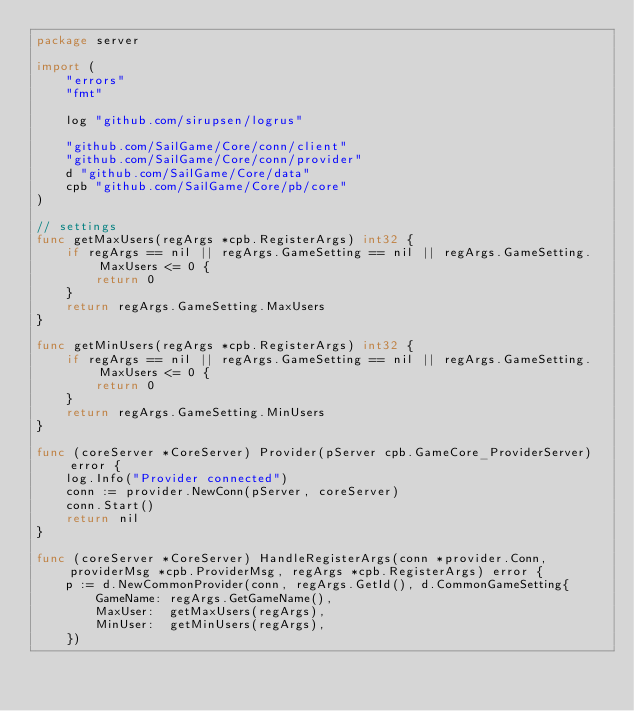Convert code to text. <code><loc_0><loc_0><loc_500><loc_500><_Go_>package server

import (
	"errors"
	"fmt"

	log "github.com/sirupsen/logrus"

	"github.com/SailGame/Core/conn/client"
	"github.com/SailGame/Core/conn/provider"
	d "github.com/SailGame/Core/data"
	cpb "github.com/SailGame/Core/pb/core"
)

// settings
func getMaxUsers(regArgs *cpb.RegisterArgs) int32 {
	if regArgs == nil || regArgs.GameSetting == nil || regArgs.GameSetting.MaxUsers <= 0 {
		return 0
	}
	return regArgs.GameSetting.MaxUsers
}

func getMinUsers(regArgs *cpb.RegisterArgs) int32 {
	if regArgs == nil || regArgs.GameSetting == nil || regArgs.GameSetting.MaxUsers <= 0 {
		return 0
	}
	return regArgs.GameSetting.MinUsers
}

func (coreServer *CoreServer) Provider(pServer cpb.GameCore_ProviderServer) error {
	log.Info("Provider connected")
	conn := provider.NewConn(pServer, coreServer)
	conn.Start()
	return nil
}

func (coreServer *CoreServer) HandleRegisterArgs(conn *provider.Conn, providerMsg *cpb.ProviderMsg, regArgs *cpb.RegisterArgs) error {
	p := d.NewCommonProvider(conn, regArgs.GetId(), d.CommonGameSetting{
		GameName: regArgs.GetGameName(),
		MaxUser:  getMaxUsers(regArgs),
		MinUser:  getMinUsers(regArgs),
	})</code> 